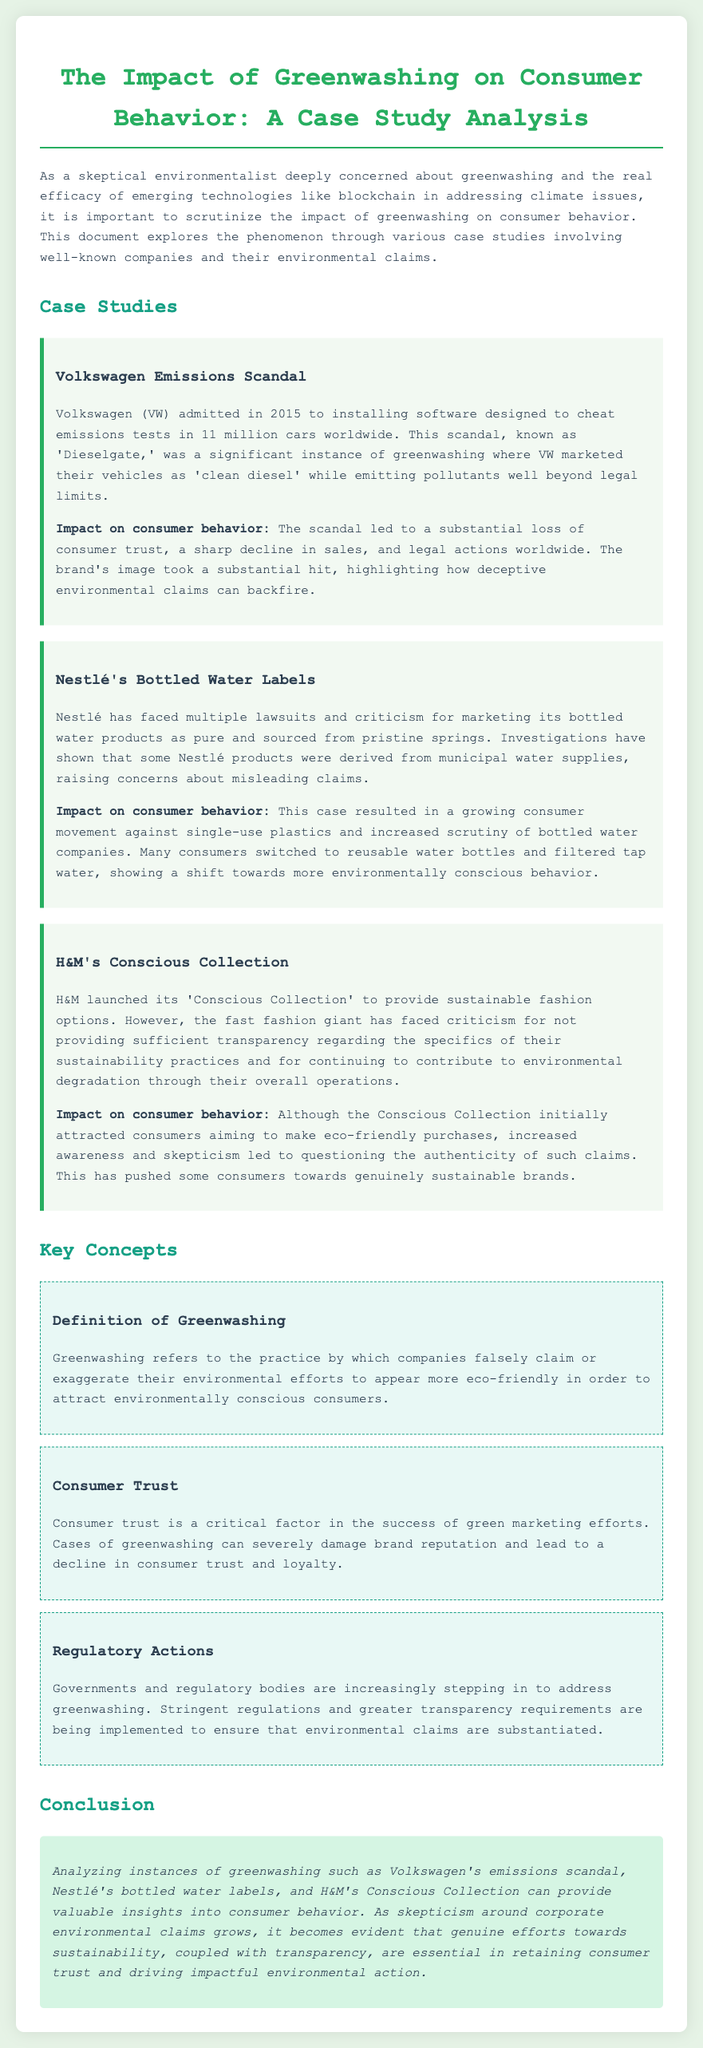What year did the Volkswagen emissions scandal occur? The document states that Volkswagen admitted to the emissions scandal in 2015.
Answer: 2015 What environmental claim was made by Volkswagen? The document notes that Volkswagen marketed their vehicles as 'clean diesel'.
Answer: clean diesel What type of product did Nestlé market as pure? The document specifies that Nestlé marketed bottled water products as pure.
Answer: bottled water What was the name of H&M's sustainable line? The case study mentions that the line is called 'Conscious Collection'.
Answer: Conscious Collection What is the definition of greenwashing according to the document? The document defines greenwashing as the practice of companies falsely claiming or exaggerating their environmental efforts.
Answer: falsely claim or exaggerate environmental efforts Which case study led to a movement against single-use plastics? The document indicates that Nestlé's bottled water labels resulted in a growing consumer movement against single-use plastics.
Answer: Nestlé's bottled water labels What is a consequence of greenwashing on consumer trust? The document explains that cases of greenwashing can severely damage brand reputation and lead to a decline in consumer trust.
Answer: decline in consumer trust What does the document suggest is essential for retaining consumer trust? The conclusion states that genuine efforts towards sustainability, coupled with transparency, are essential in retaining consumer trust.
Answer: transparency How many cars were involved in the Volkswagen emissions scandal? The document specifies that Volkswagen installed software in 11 million cars worldwide.
Answer: 11 million 